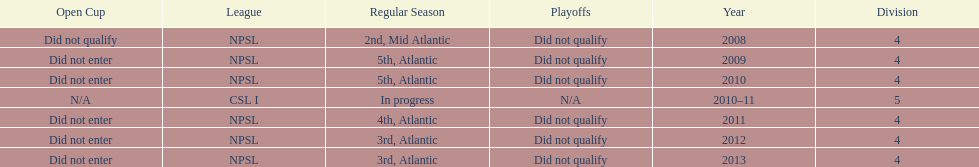What is the lowest place they came in 5th. 